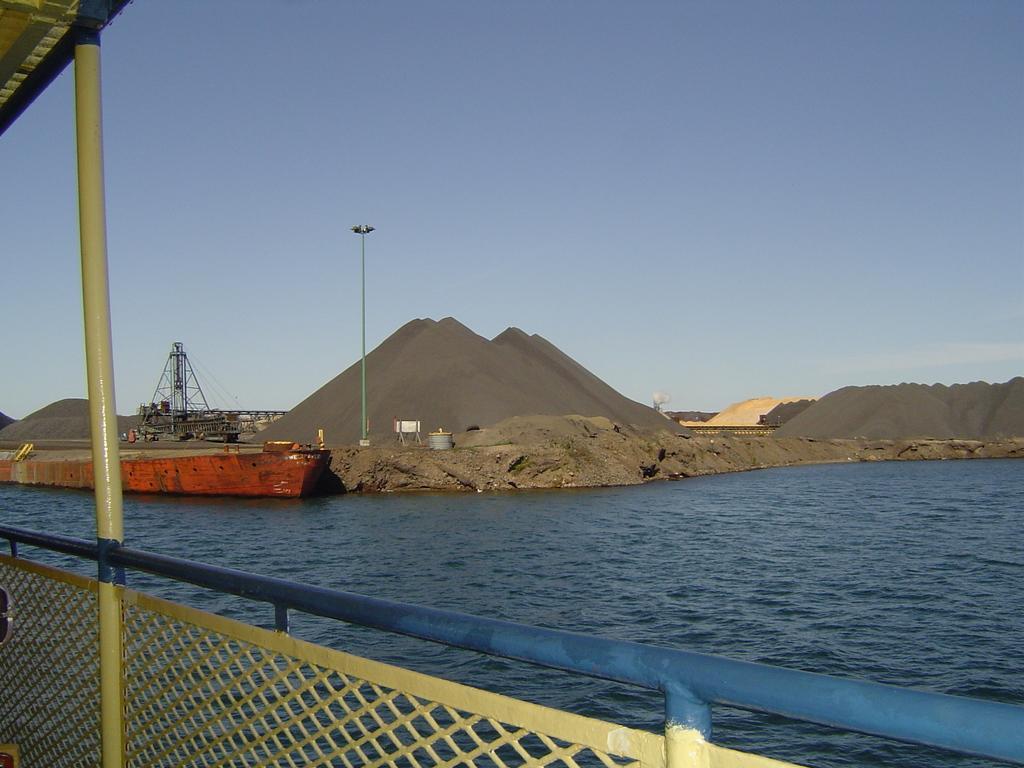In one or two sentences, can you explain what this image depicts? In this image we can see one object with pole on the left side of the image, one fence, two objects near the fence, one light with pole, one river, some objects on the ground, dome mud near the river, one boat on the river, some objects looks like sand on the ground and at the top there is the sky. 